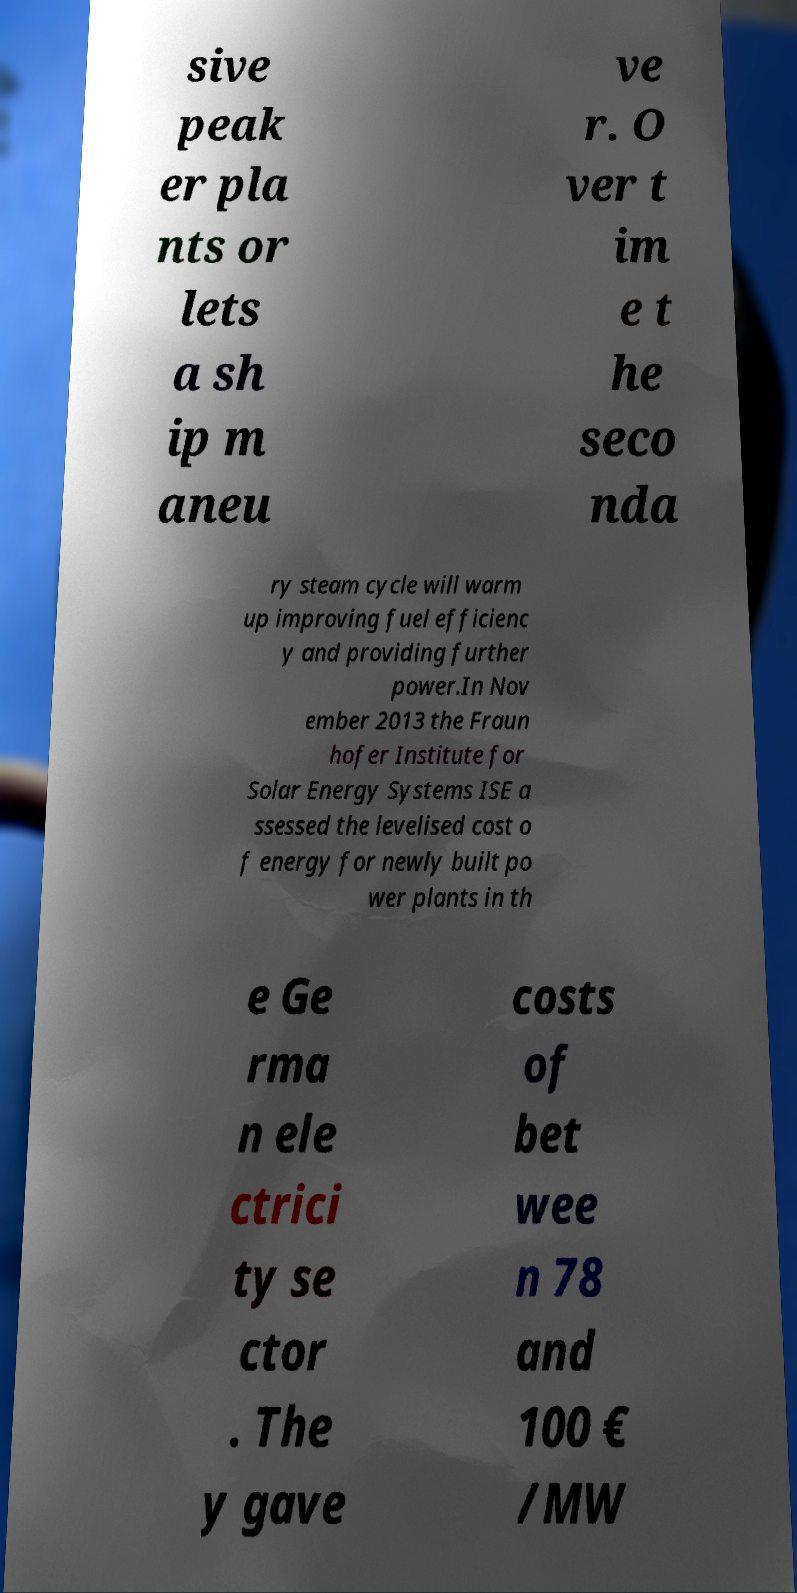Can you read and provide the text displayed in the image?This photo seems to have some interesting text. Can you extract and type it out for me? sive peak er pla nts or lets a sh ip m aneu ve r. O ver t im e t he seco nda ry steam cycle will warm up improving fuel efficienc y and providing further power.In Nov ember 2013 the Fraun hofer Institute for Solar Energy Systems ISE a ssessed the levelised cost o f energy for newly built po wer plants in th e Ge rma n ele ctrici ty se ctor . The y gave costs of bet wee n 78 and 100 € /MW 